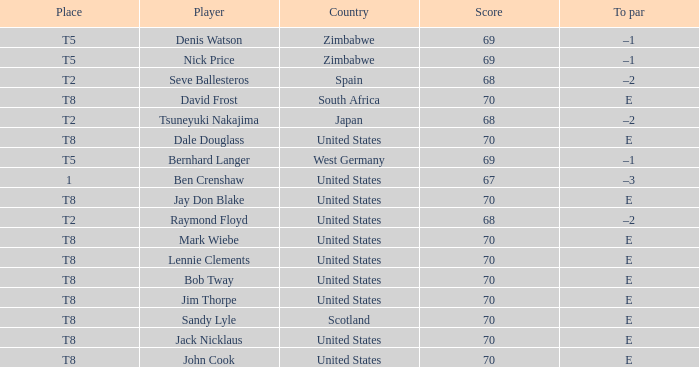What place has E as the to par, with Mark Wiebe as the player? T8. 